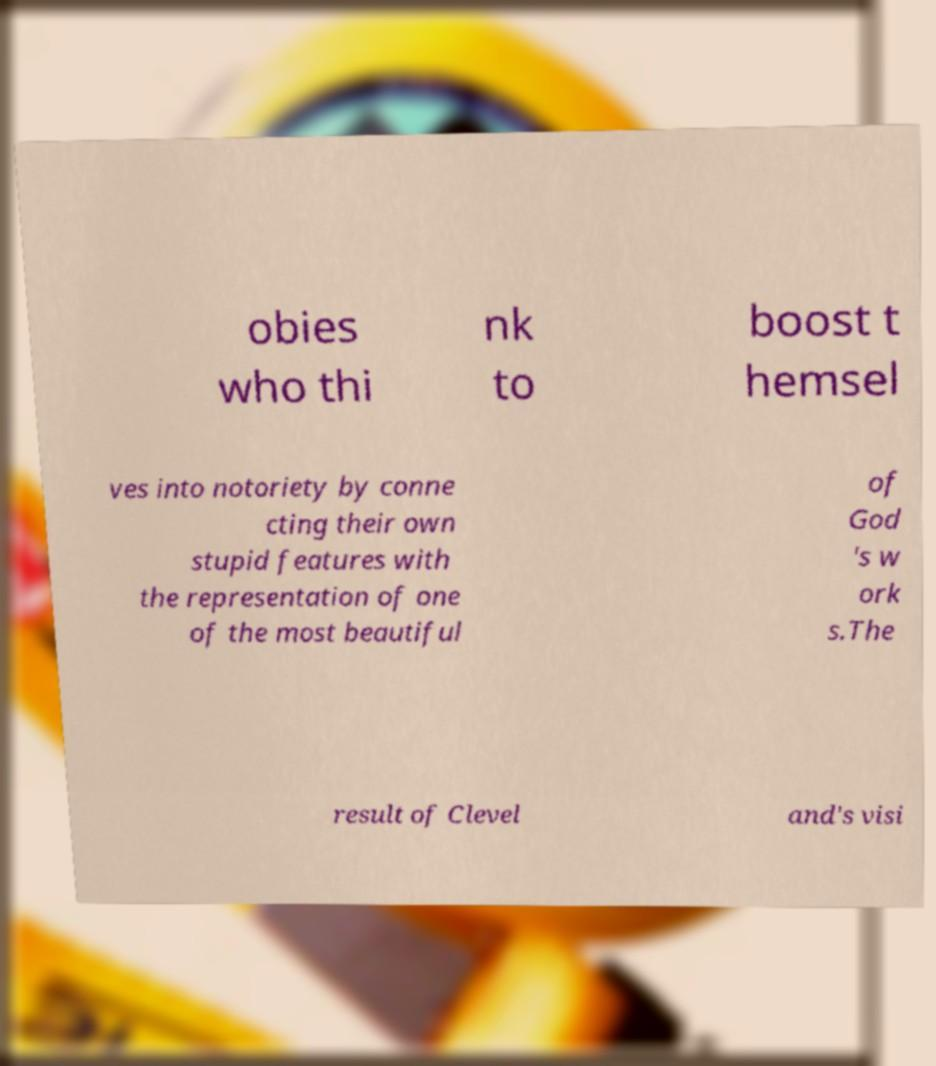What messages or text are displayed in this image? I need them in a readable, typed format. obies who thi nk to boost t hemsel ves into notoriety by conne cting their own stupid features with the representation of one of the most beautiful of God 's w ork s.The result of Clevel and's visi 